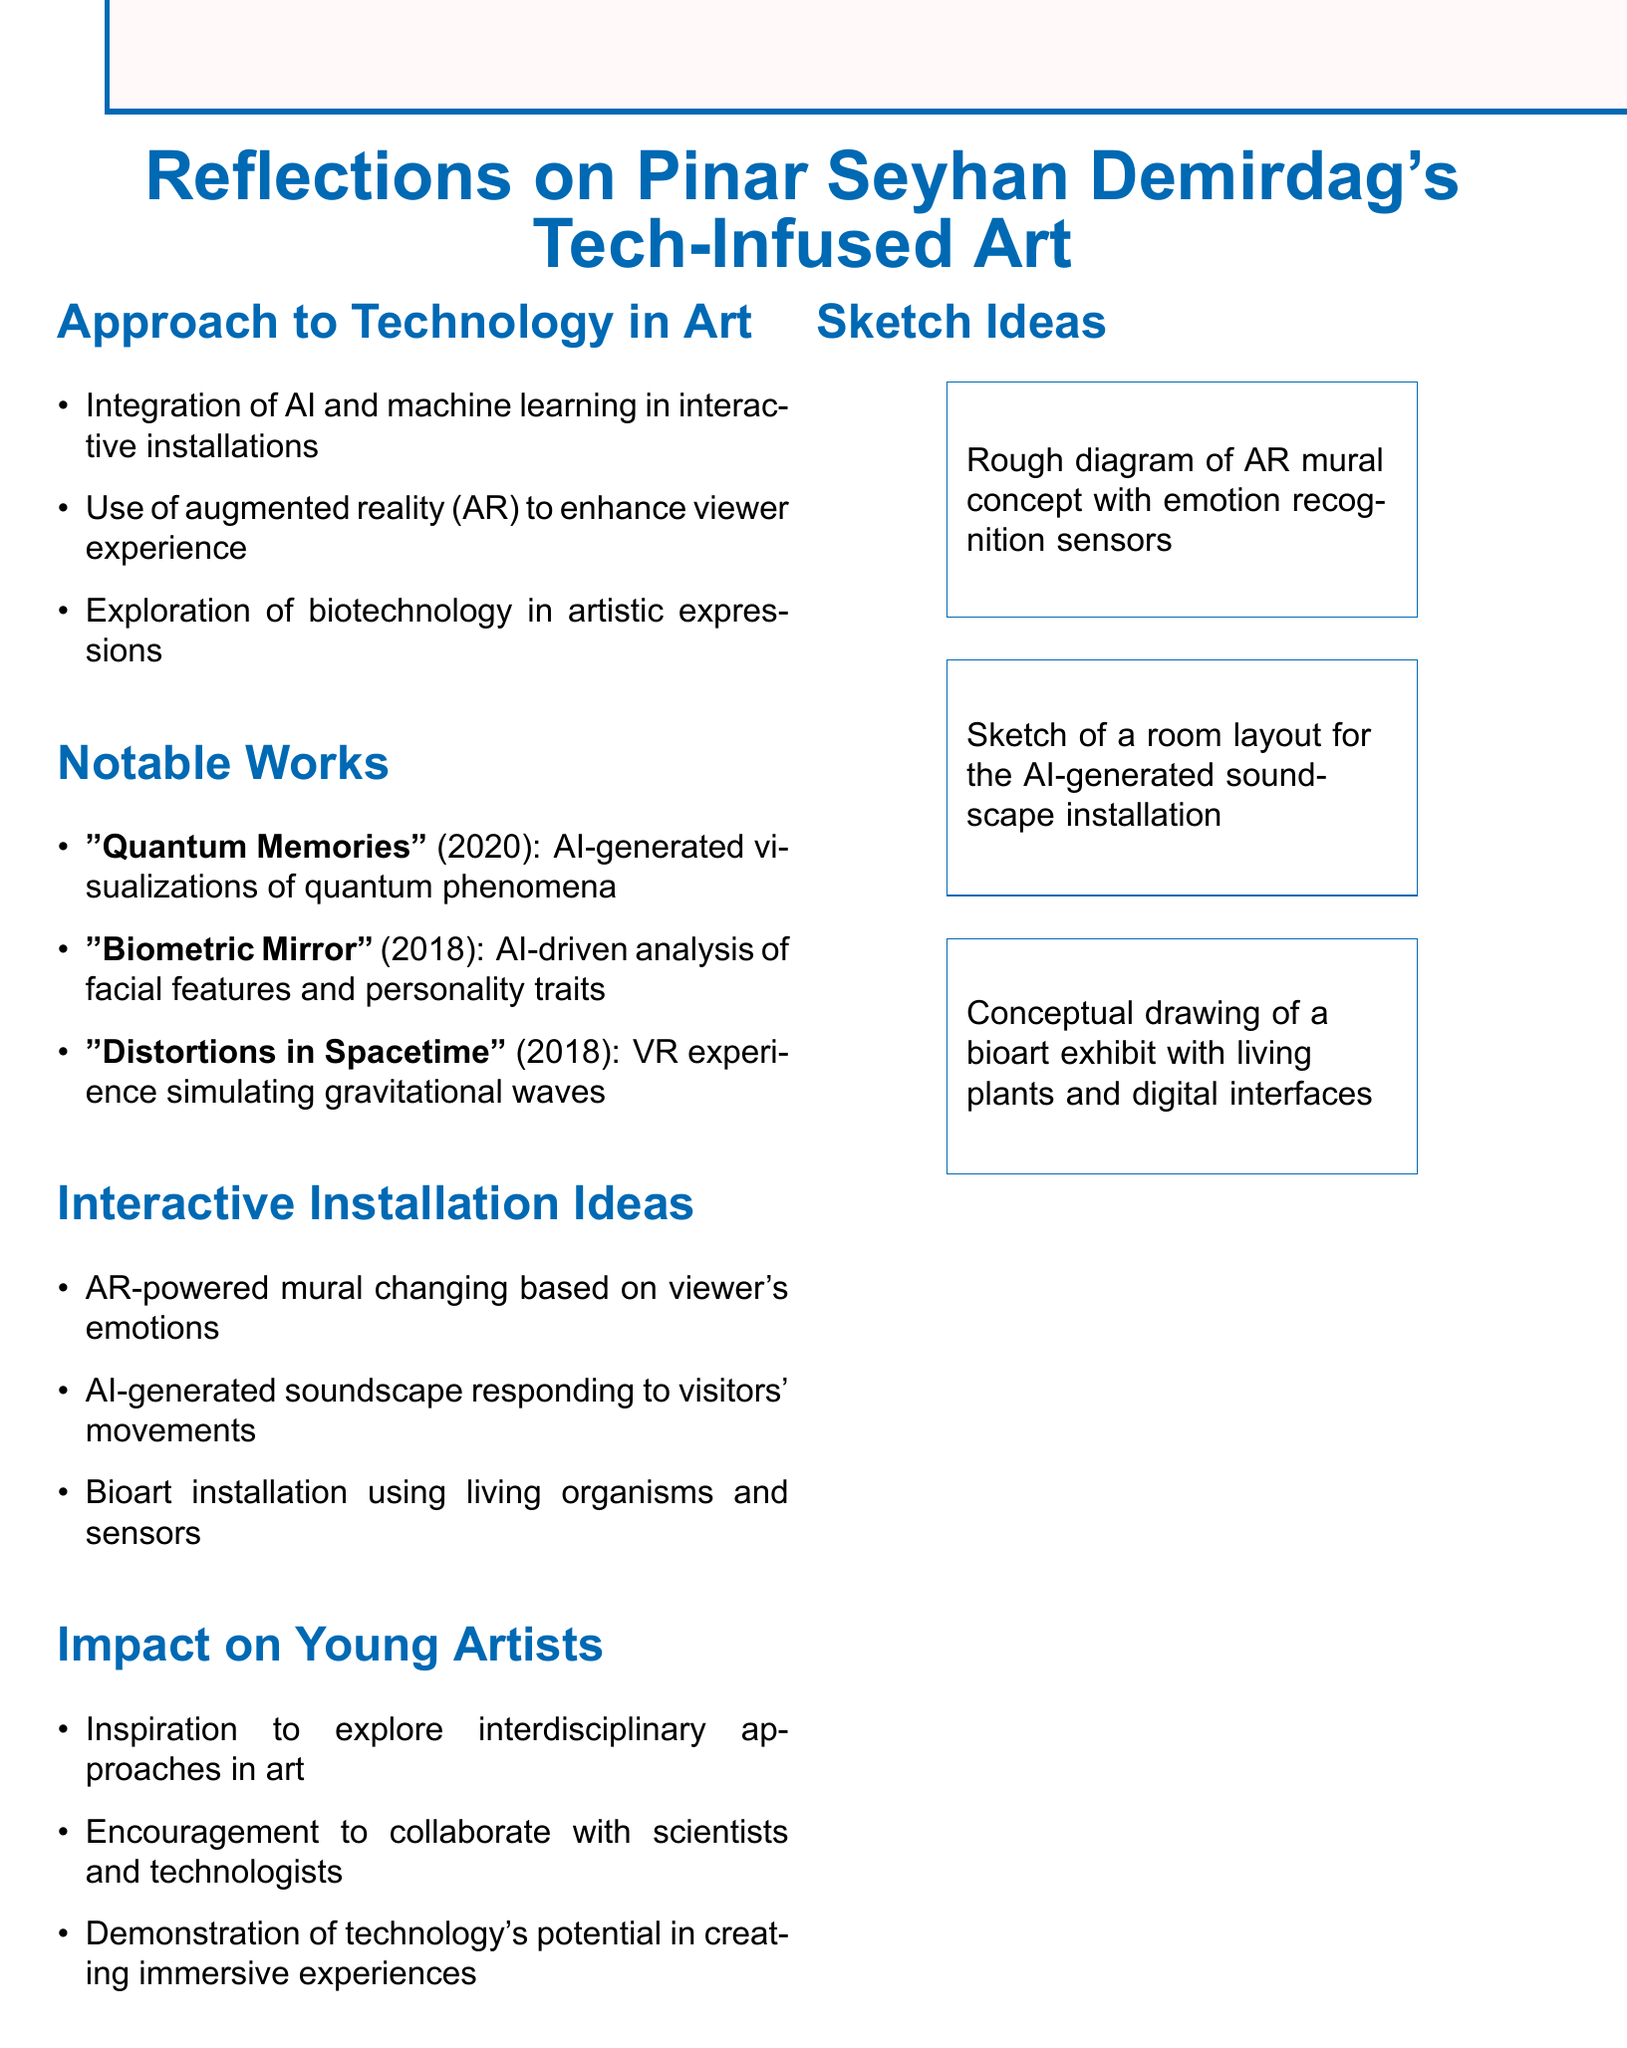What technology does Pinar Seyhan Demirdag integrate into her art? The document mentions AI and machine learning as integrated technologies in her art.
Answer: AI and machine learning What year was "Biometric Mirror" created? The document states that "Biometric Mirror" was released in 2018.
Answer: 2018 What is the focus of the AR-powered mural installation idea? The installation idea focuses on changing based on viewers' emotions.
Answer: Viewer’s emotions Which installation simulates gravitational waves? The document identifies "Distortions in Spacetime" as the installation simulating gravitational waves.
Answer: Distortions in Spacetime What does Pinar Seyhan Demirdag encourage young artists to do? The document indicates encouragement for young artists to collaborate with scientists and technologists.
Answer: Collaborate Which notable work features AI-generated visualizations of quantum phenomena? The work "Quantum Memories" is noted for its AI-generated visualizations of quantum phenomena.
Answer: Quantum Memories What is a potential use of biotechnology mentioned in the document? The document mentions exploration of biotechnology as a tool for artistic expressions.
Answer: Artistic expressions How many interactive installation ideas are listed in the document? The document provides three potential interactive installation ideas.
Answer: Three 